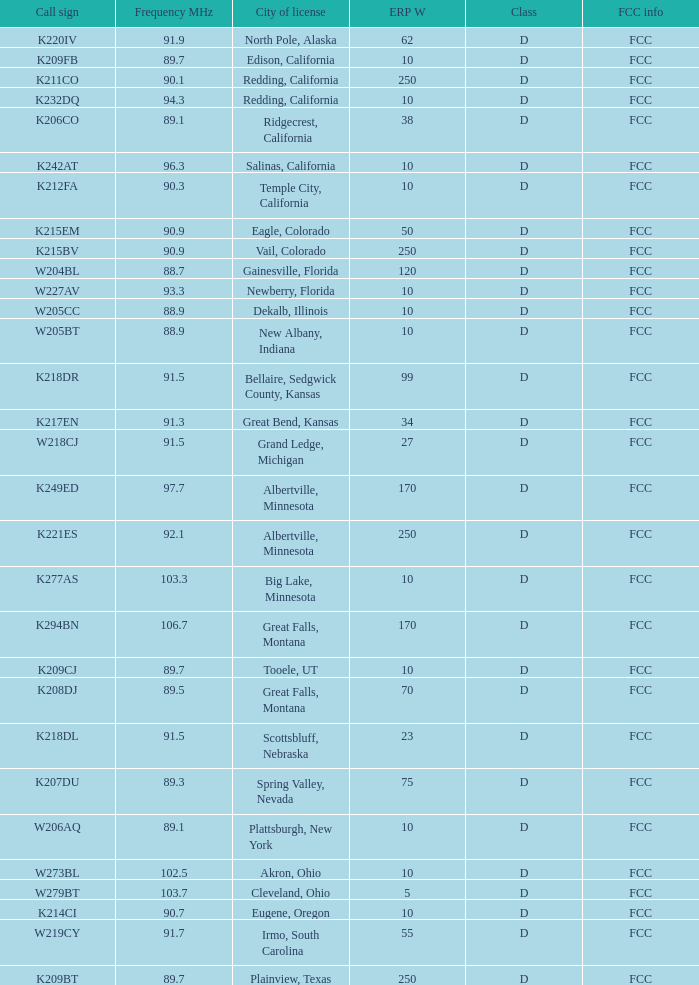What is the call sign of the translator in Spring Valley, Nevada? K207DU. 